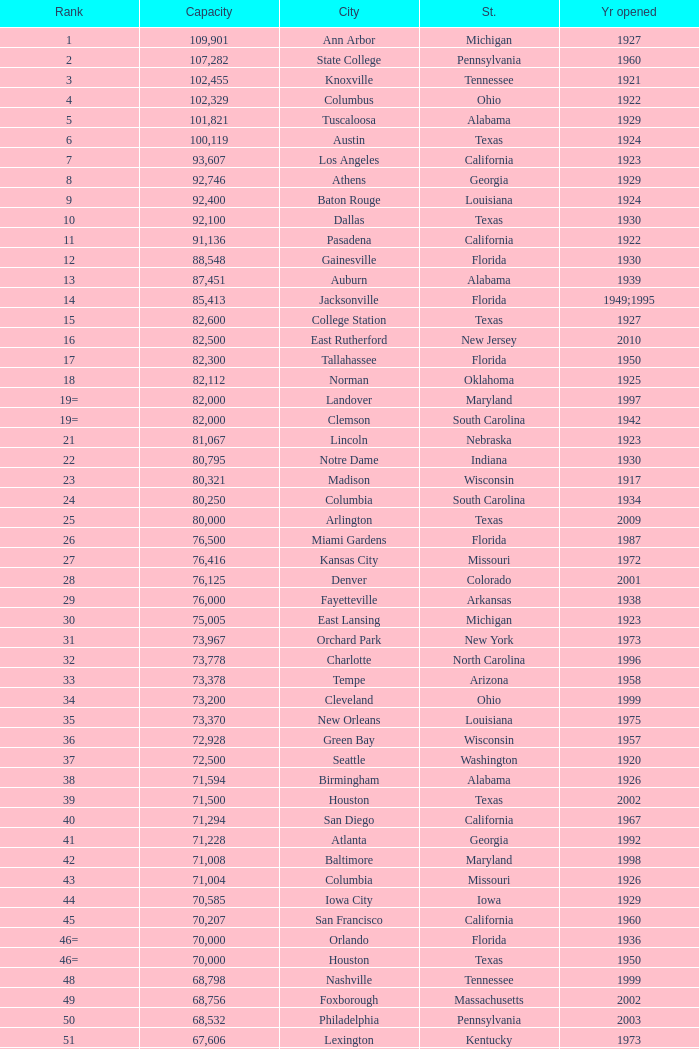What is the lowest capacity for 1903? 30323.0. 